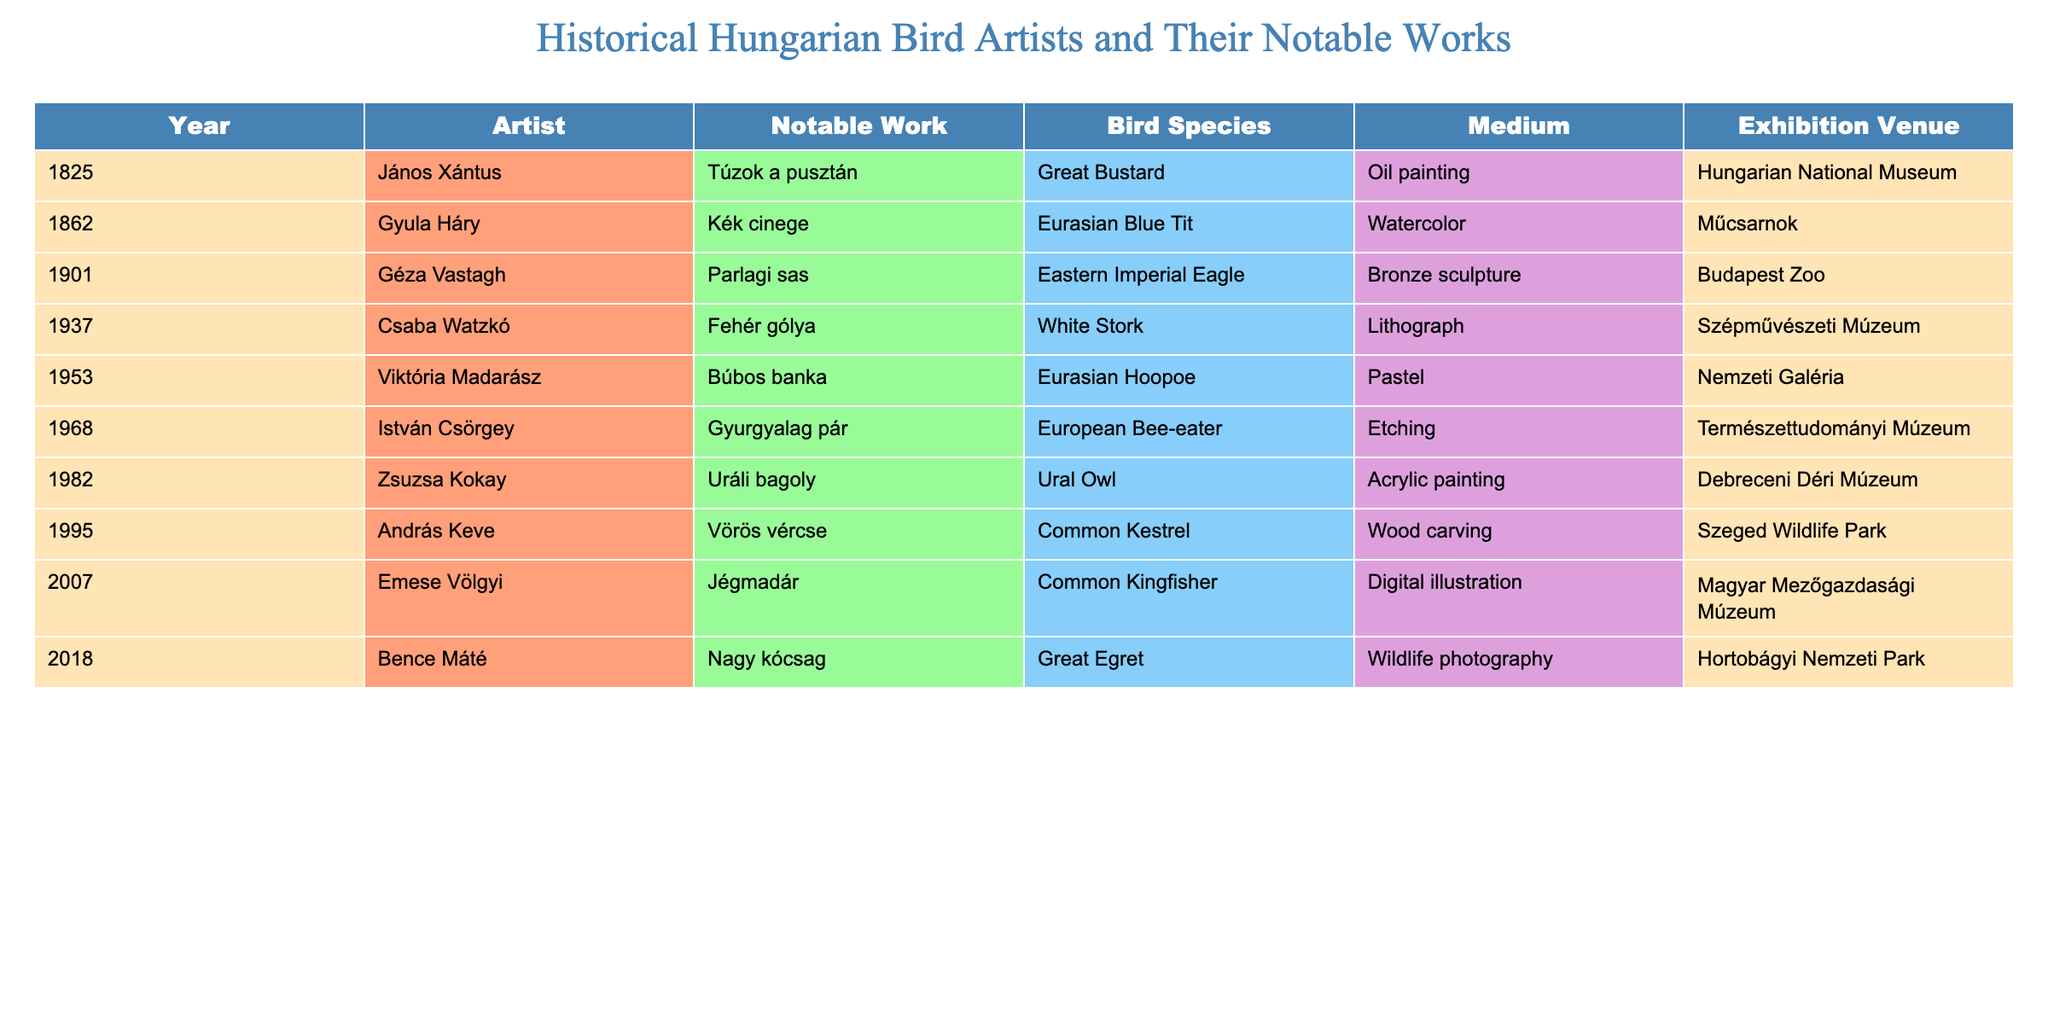What year did János Xántus create his notable work? János Xántus's notable work, "Túzok a pusztán," was created in the year 1825, which can be found in the Year column next to his name in the table.
Answer: 1825 Which artist created a work featuring the Eurasian Blue Tit? The artist who created a work featuring the Eurasian Blue Tit is Gyula Háry, as indicated in the Bird Species column alongside his name in the table.
Answer: Gyula Háry What medium was used for the artwork "Fehér gólya"? The medium used for "Fehér gólya" by Csaba Watzkó is lithograph, which is listed in the Medium column corresponding to his entry.
Answer: Lithograph Who exhibited their artwork at the Szépművészeti Múzeum? Csaba Watzkó exhibited his artwork at the Szépművészeti Múzeum, as shown in the Exhibition Venue column next to his name in the table.
Answer: Csaba Watzkó How many artists created works of bird art in the 20th century? There are 6 artists listed with works created in the 20th century (1901, 1937, 1953, 1968, 1982, 1995), counting their corresponding entries in the Year column.
Answer: 6 What is the average year of creation for the artworks listed in the table? To find the average, sum the years (1825 + 1862 + 1901 + 1937 + 1953 + 1968 + 1982 + 1995 + 2007 + 2018 = 19548), then divide by the total number of artworks (10): 19548 / 10 = 1954.8. Thus, the average year is approximately 1955.
Answer: 1955 Is the "Ural Owl" artwork created by a female artist? Yes, the "Ural Owl," created by Zsuzsa Kokay, indicates that the artist is female, as evidenced by her name in the Artist column of the table.
Answer: Yes Which bird species did Viktória Madarász depict, and in what year? Viktória Madarász depicted the Eurasian Hoopoe in the year 1953, as noted in the table under the respective columns for Notable Work and Year.
Answer: Eurasian Hoopoe, 1953 What is the total number of distinct bird species represented in the table? The distinct bird species represented are: Great Bustard, Eurasian Blue Tit, Eastern Imperial Eagle, White Stork, Eurasian Hoopoe, European Bee-eater, Ural Owl, Common Kestrel, Common Kingfisher, and Great Egret—counting these yields a total of 10 distinct species represented.
Answer: 10 Who had the most recent exhibition venue listed? Bence Máté had the most recent exhibition venue, Hortobágyi Nemzeti Park, as it corresponds to the most recent year (2018) listed in the table.
Answer: Bence Máté 